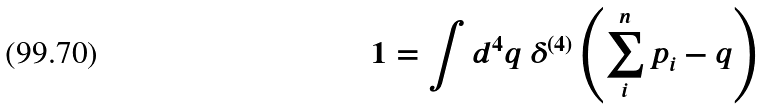<formula> <loc_0><loc_0><loc_500><loc_500>1 = \int d ^ { 4 } q \ \delta ^ { ( 4 ) } \left ( \sum _ { i } ^ { n } p _ { i } - q \right )</formula> 